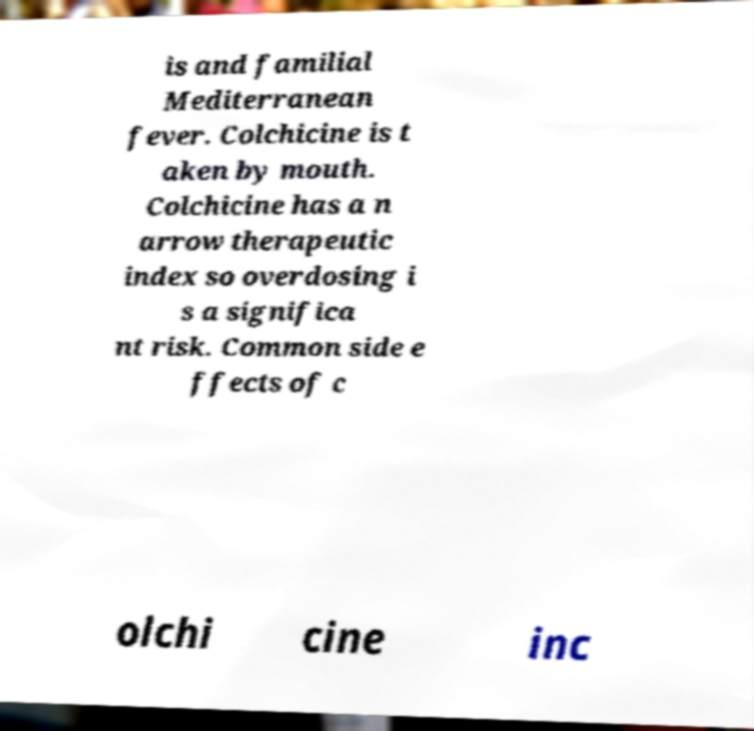There's text embedded in this image that I need extracted. Can you transcribe it verbatim? is and familial Mediterranean fever. Colchicine is t aken by mouth. Colchicine has a n arrow therapeutic index so overdosing i s a significa nt risk. Common side e ffects of c olchi cine inc 